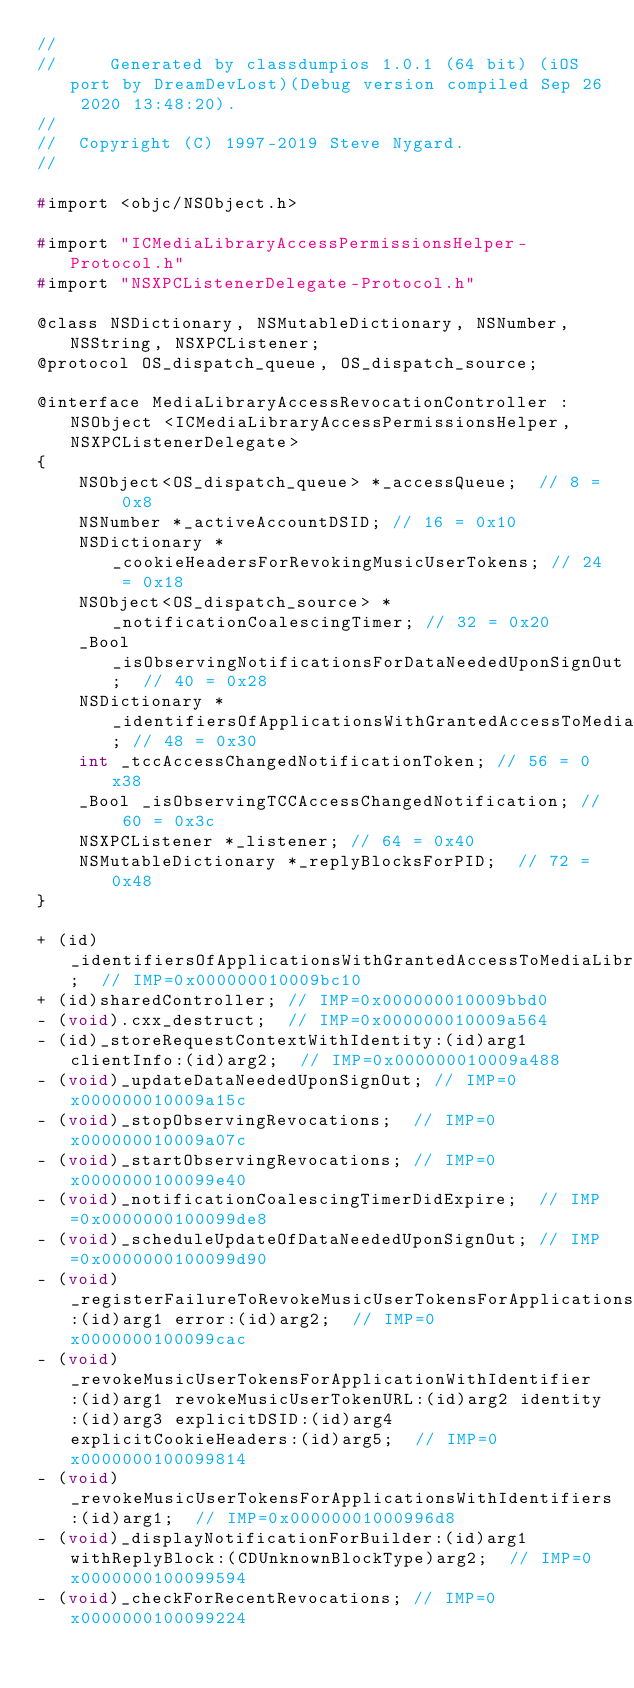<code> <loc_0><loc_0><loc_500><loc_500><_C_>//
//     Generated by classdumpios 1.0.1 (64 bit) (iOS port by DreamDevLost)(Debug version compiled Sep 26 2020 13:48:20).
//
//  Copyright (C) 1997-2019 Steve Nygard.
//

#import <objc/NSObject.h>

#import "ICMediaLibraryAccessPermissionsHelper-Protocol.h"
#import "NSXPCListenerDelegate-Protocol.h"

@class NSDictionary, NSMutableDictionary, NSNumber, NSString, NSXPCListener;
@protocol OS_dispatch_queue, OS_dispatch_source;

@interface MediaLibraryAccessRevocationController : NSObject <ICMediaLibraryAccessPermissionsHelper, NSXPCListenerDelegate>
{
    NSObject<OS_dispatch_queue> *_accessQueue;	// 8 = 0x8
    NSNumber *_activeAccountDSID;	// 16 = 0x10
    NSDictionary *_cookieHeadersForRevokingMusicUserTokens;	// 24 = 0x18
    NSObject<OS_dispatch_source> *_notificationCoalescingTimer;	// 32 = 0x20
    _Bool _isObservingNotificationsForDataNeededUponSignOut;	// 40 = 0x28
    NSDictionary *_identifiersOfApplicationsWithGrantedAccessToMediaLibraryIncludingTCCAcceptanceDates;	// 48 = 0x30
    int _tccAccessChangedNotificationToken;	// 56 = 0x38
    _Bool _isObservingTCCAccessChangedNotification;	// 60 = 0x3c
    NSXPCListener *_listener;	// 64 = 0x40
    NSMutableDictionary *_replyBlocksForPID;	// 72 = 0x48
}

+ (id)_identifiersOfApplicationsWithGrantedAccessToMediaLibrary;	// IMP=0x000000010009bc10
+ (id)sharedController;	// IMP=0x000000010009bbd0
- (void).cxx_destruct;	// IMP=0x000000010009a564
- (id)_storeRequestContextWithIdentity:(id)arg1 clientInfo:(id)arg2;	// IMP=0x000000010009a488
- (void)_updateDataNeededUponSignOut;	// IMP=0x000000010009a15c
- (void)_stopObservingRevocations;	// IMP=0x000000010009a07c
- (void)_startObservingRevocations;	// IMP=0x0000000100099e40
- (void)_notificationCoalescingTimerDidExpire;	// IMP=0x0000000100099de8
- (void)_scheduleUpdateOfDataNeededUponSignOut;	// IMP=0x0000000100099d90
- (void)_registerFailureToRevokeMusicUserTokensForApplicationsWithIdentifiers:(id)arg1 error:(id)arg2;	// IMP=0x0000000100099cac
- (void)_revokeMusicUserTokensForApplicationWithIdentifier:(id)arg1 revokeMusicUserTokenURL:(id)arg2 identity:(id)arg3 explicitDSID:(id)arg4 explicitCookieHeaders:(id)arg5;	// IMP=0x0000000100099814
- (void)_revokeMusicUserTokensForApplicationsWithIdentifiers:(id)arg1;	// IMP=0x00000001000996d8
- (void)_displayNotificationForBuilder:(id)arg1 withReplyBlock:(CDUnknownBlockType)arg2;	// IMP=0x0000000100099594
- (void)_checkForRecentRevocations;	// IMP=0x0000000100099224</code> 